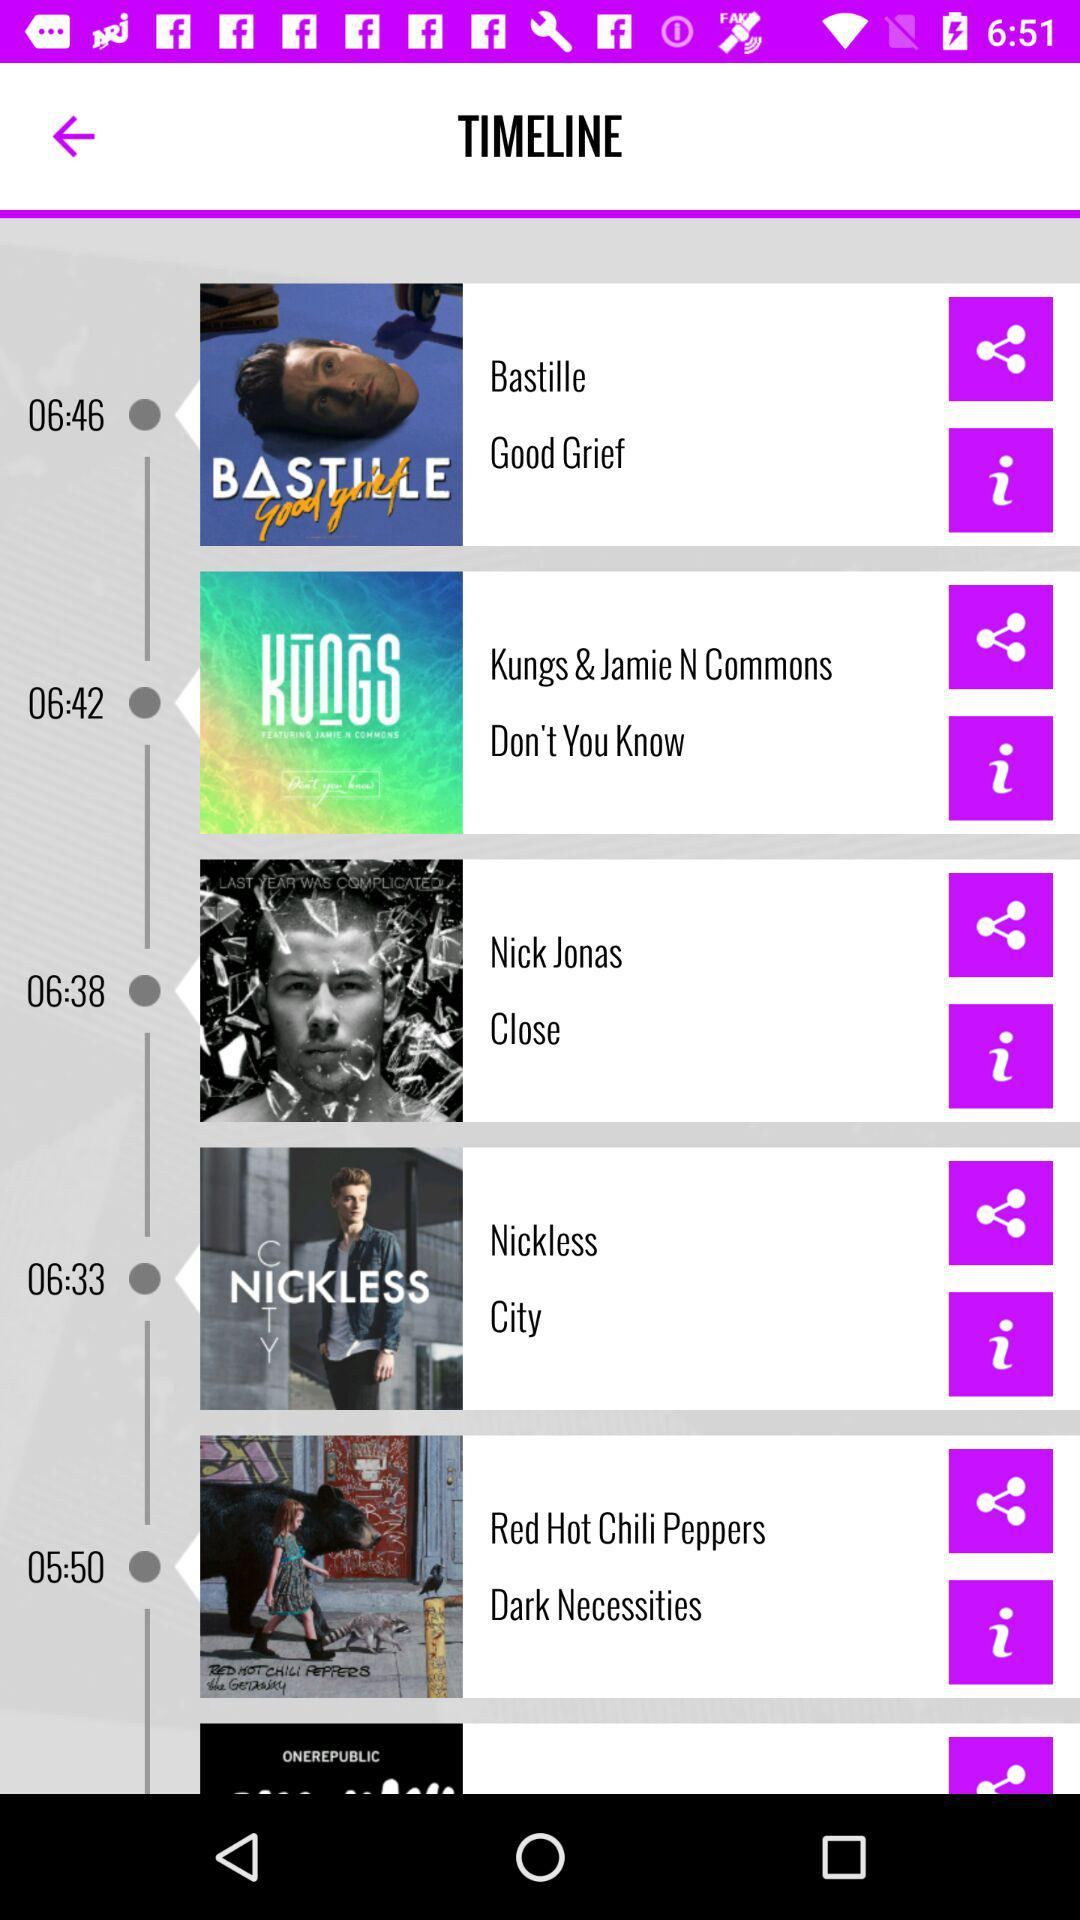How many items are in the timeline?
Answer the question using a single word or phrase. 6 